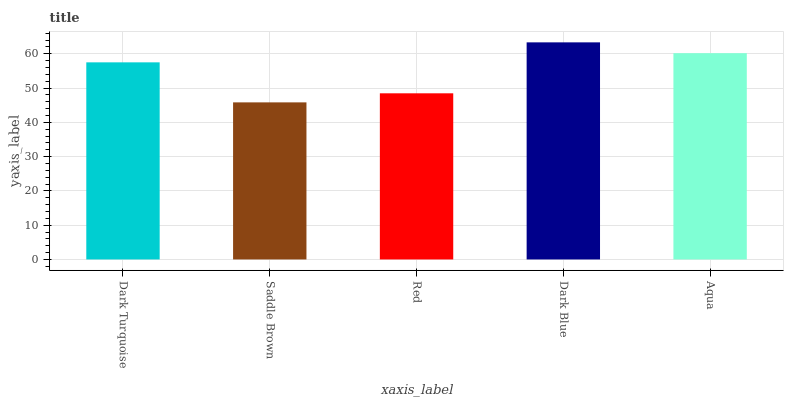Is Red the minimum?
Answer yes or no. No. Is Red the maximum?
Answer yes or no. No. Is Red greater than Saddle Brown?
Answer yes or no. Yes. Is Saddle Brown less than Red?
Answer yes or no. Yes. Is Saddle Brown greater than Red?
Answer yes or no. No. Is Red less than Saddle Brown?
Answer yes or no. No. Is Dark Turquoise the high median?
Answer yes or no. Yes. Is Dark Turquoise the low median?
Answer yes or no. Yes. Is Red the high median?
Answer yes or no. No. Is Aqua the low median?
Answer yes or no. No. 